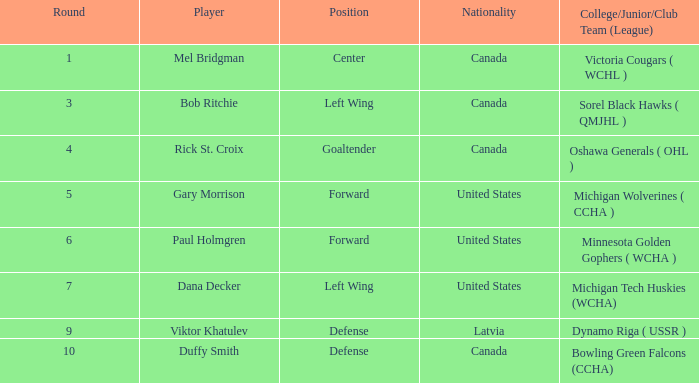Can you identify a player who is a forward from the united states and has taken part in over 5 rounds? Paul Holmgren. 